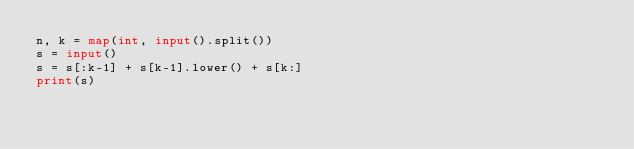<code> <loc_0><loc_0><loc_500><loc_500><_Python_>n, k = map(int, input().split())
s = input()
s = s[:k-1] + s[k-1].lower() + s[k:]
print(s)</code> 